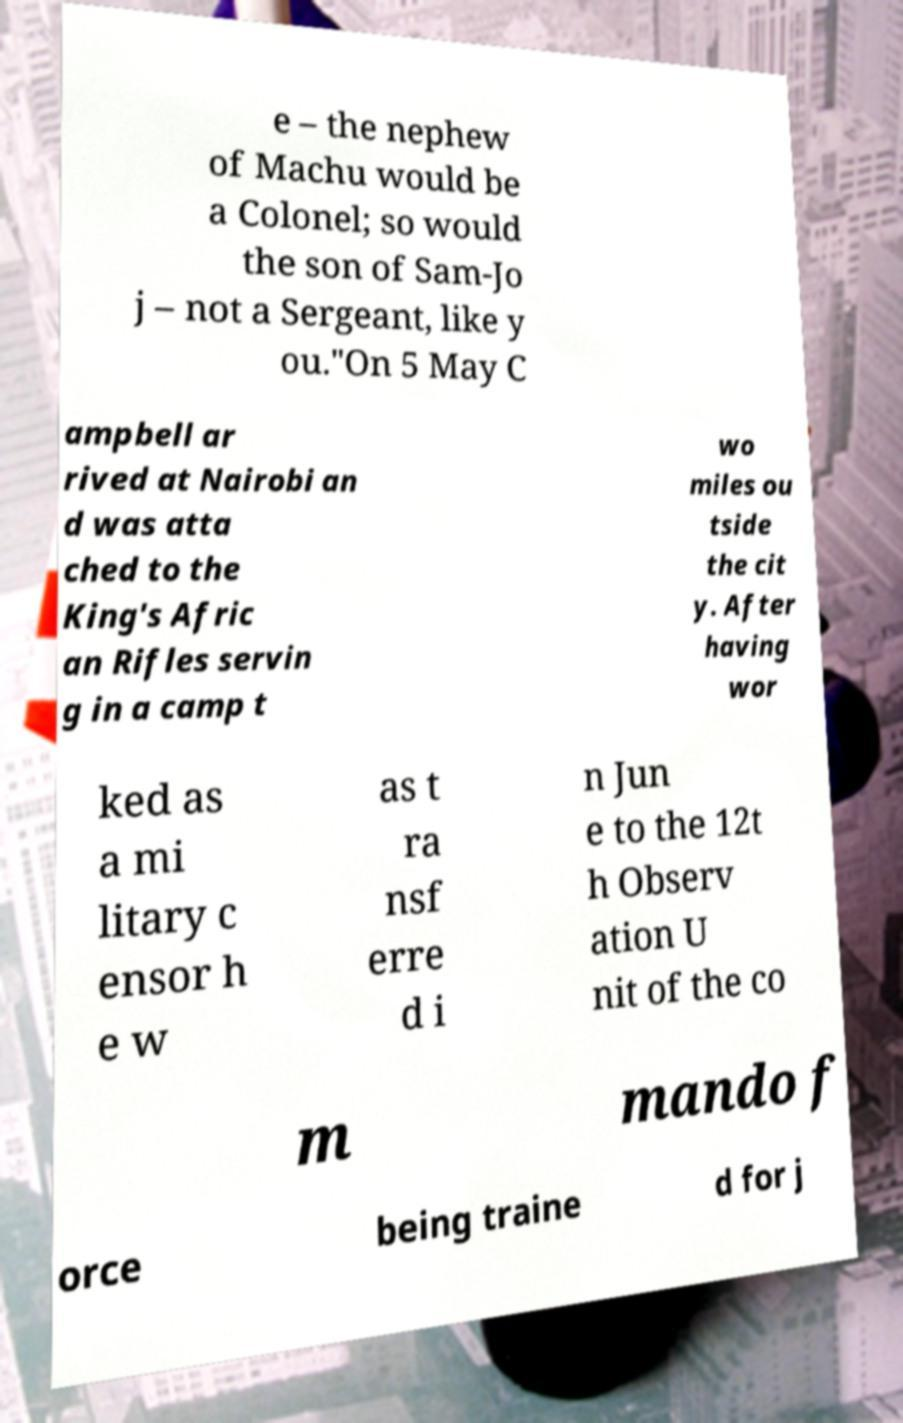For documentation purposes, I need the text within this image transcribed. Could you provide that? e – the nephew of Machu would be a Colonel; so would the son of Sam-Jo j – not a Sergeant, like y ou."On 5 May C ampbell ar rived at Nairobi an d was atta ched to the King's Afric an Rifles servin g in a camp t wo miles ou tside the cit y. After having wor ked as a mi litary c ensor h e w as t ra nsf erre d i n Jun e to the 12t h Observ ation U nit of the co m mando f orce being traine d for j 